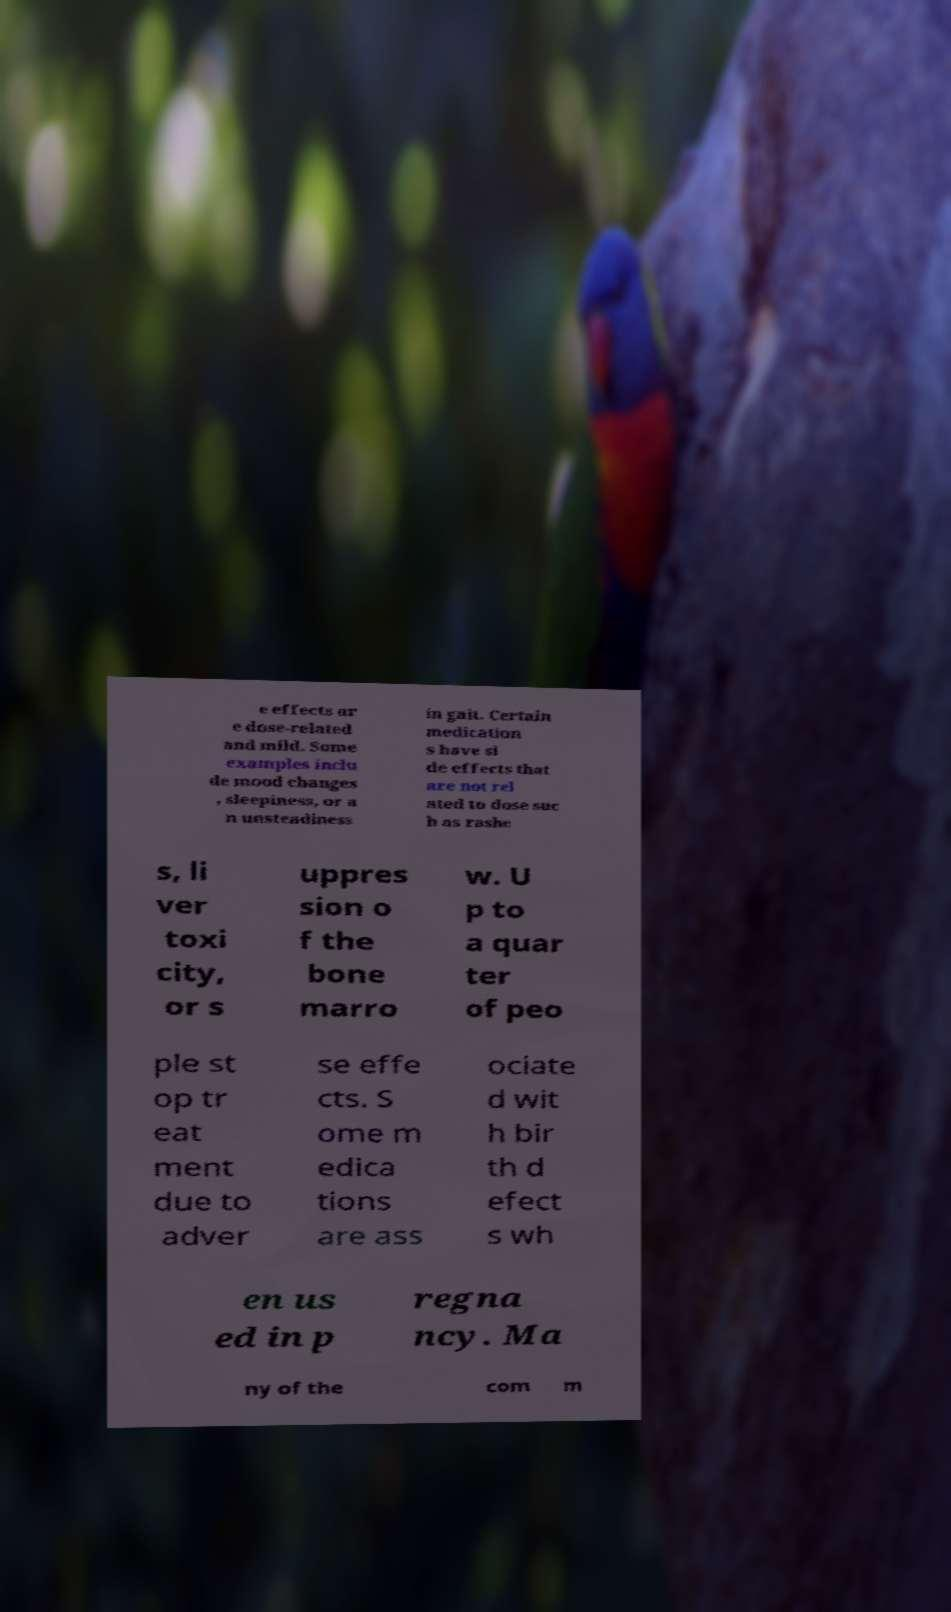Can you read and provide the text displayed in the image?This photo seems to have some interesting text. Can you extract and type it out for me? e effects ar e dose-related and mild. Some examples inclu de mood changes , sleepiness, or a n unsteadiness in gait. Certain medication s have si de effects that are not rel ated to dose suc h as rashe s, li ver toxi city, or s uppres sion o f the bone marro w. U p to a quar ter of peo ple st op tr eat ment due to adver se effe cts. S ome m edica tions are ass ociate d wit h bir th d efect s wh en us ed in p regna ncy. Ma ny of the com m 